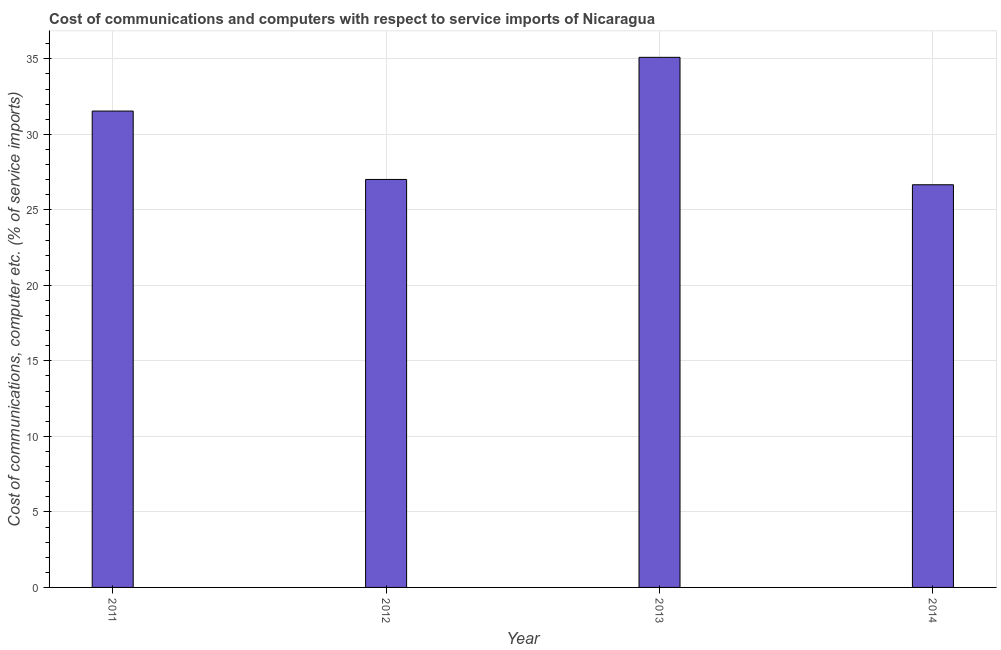Does the graph contain grids?
Offer a terse response. Yes. What is the title of the graph?
Your answer should be compact. Cost of communications and computers with respect to service imports of Nicaragua. What is the label or title of the Y-axis?
Ensure brevity in your answer.  Cost of communications, computer etc. (% of service imports). What is the cost of communications and computer in 2011?
Give a very brief answer. 31.54. Across all years, what is the maximum cost of communications and computer?
Give a very brief answer. 35.1. Across all years, what is the minimum cost of communications and computer?
Ensure brevity in your answer.  26.66. In which year was the cost of communications and computer minimum?
Your answer should be very brief. 2014. What is the sum of the cost of communications and computer?
Provide a succinct answer. 120.31. What is the difference between the cost of communications and computer in 2011 and 2013?
Your answer should be compact. -3.56. What is the average cost of communications and computer per year?
Your answer should be very brief. 30.08. What is the median cost of communications and computer?
Your response must be concise. 29.28. In how many years, is the cost of communications and computer greater than 28 %?
Your response must be concise. 2. What is the ratio of the cost of communications and computer in 2011 to that in 2014?
Your response must be concise. 1.18. Is the cost of communications and computer in 2012 less than that in 2013?
Make the answer very short. Yes. What is the difference between the highest and the second highest cost of communications and computer?
Offer a very short reply. 3.56. What is the difference between the highest and the lowest cost of communications and computer?
Give a very brief answer. 8.44. In how many years, is the cost of communications and computer greater than the average cost of communications and computer taken over all years?
Ensure brevity in your answer.  2. Are all the bars in the graph horizontal?
Ensure brevity in your answer.  No. What is the difference between two consecutive major ticks on the Y-axis?
Keep it short and to the point. 5. What is the Cost of communications, computer etc. (% of service imports) of 2011?
Give a very brief answer. 31.54. What is the Cost of communications, computer etc. (% of service imports) in 2012?
Your answer should be compact. 27.01. What is the Cost of communications, computer etc. (% of service imports) of 2013?
Keep it short and to the point. 35.1. What is the Cost of communications, computer etc. (% of service imports) of 2014?
Offer a very short reply. 26.66. What is the difference between the Cost of communications, computer etc. (% of service imports) in 2011 and 2012?
Ensure brevity in your answer.  4.53. What is the difference between the Cost of communications, computer etc. (% of service imports) in 2011 and 2013?
Offer a very short reply. -3.56. What is the difference between the Cost of communications, computer etc. (% of service imports) in 2011 and 2014?
Your response must be concise. 4.88. What is the difference between the Cost of communications, computer etc. (% of service imports) in 2012 and 2013?
Offer a terse response. -8.09. What is the difference between the Cost of communications, computer etc. (% of service imports) in 2012 and 2014?
Provide a short and direct response. 0.35. What is the difference between the Cost of communications, computer etc. (% of service imports) in 2013 and 2014?
Offer a terse response. 8.44. What is the ratio of the Cost of communications, computer etc. (% of service imports) in 2011 to that in 2012?
Ensure brevity in your answer.  1.17. What is the ratio of the Cost of communications, computer etc. (% of service imports) in 2011 to that in 2013?
Provide a short and direct response. 0.9. What is the ratio of the Cost of communications, computer etc. (% of service imports) in 2011 to that in 2014?
Ensure brevity in your answer.  1.18. What is the ratio of the Cost of communications, computer etc. (% of service imports) in 2012 to that in 2013?
Your answer should be compact. 0.77. What is the ratio of the Cost of communications, computer etc. (% of service imports) in 2013 to that in 2014?
Ensure brevity in your answer.  1.32. 